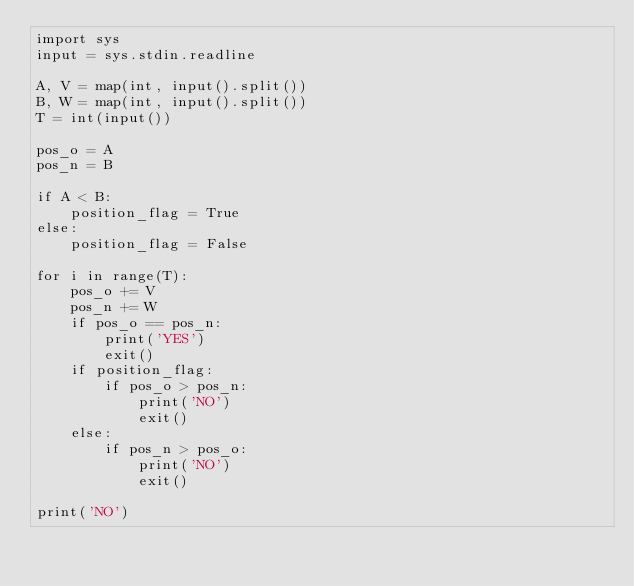Convert code to text. <code><loc_0><loc_0><loc_500><loc_500><_Python_>import sys
input = sys.stdin.readline

A, V = map(int, input().split())
B, W = map(int, input().split())
T = int(input())

pos_o = A
pos_n = B

if A < B:
    position_flag = True
else:
    position_flag = False

for i in range(T):
    pos_o += V
    pos_n += W
    if pos_o == pos_n:
        print('YES')
        exit()
    if position_flag:
        if pos_o > pos_n:
            print('NO')
            exit()
    else:
        if pos_n > pos_o:
            print('NO')
            exit()

print('NO')
</code> 